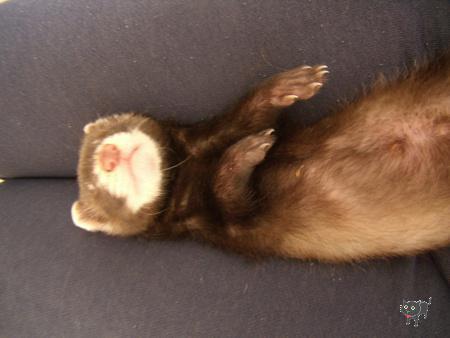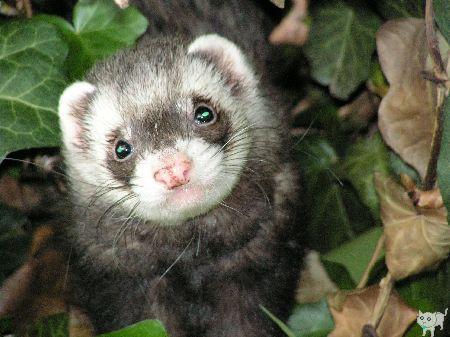The first image is the image on the left, the second image is the image on the right. For the images shown, is this caption "There are at most two ferrets." true? Answer yes or no. Yes. The first image is the image on the left, the second image is the image on the right. Analyze the images presented: Is the assertion "There are at least three total rodents." valid? Answer yes or no. No. 